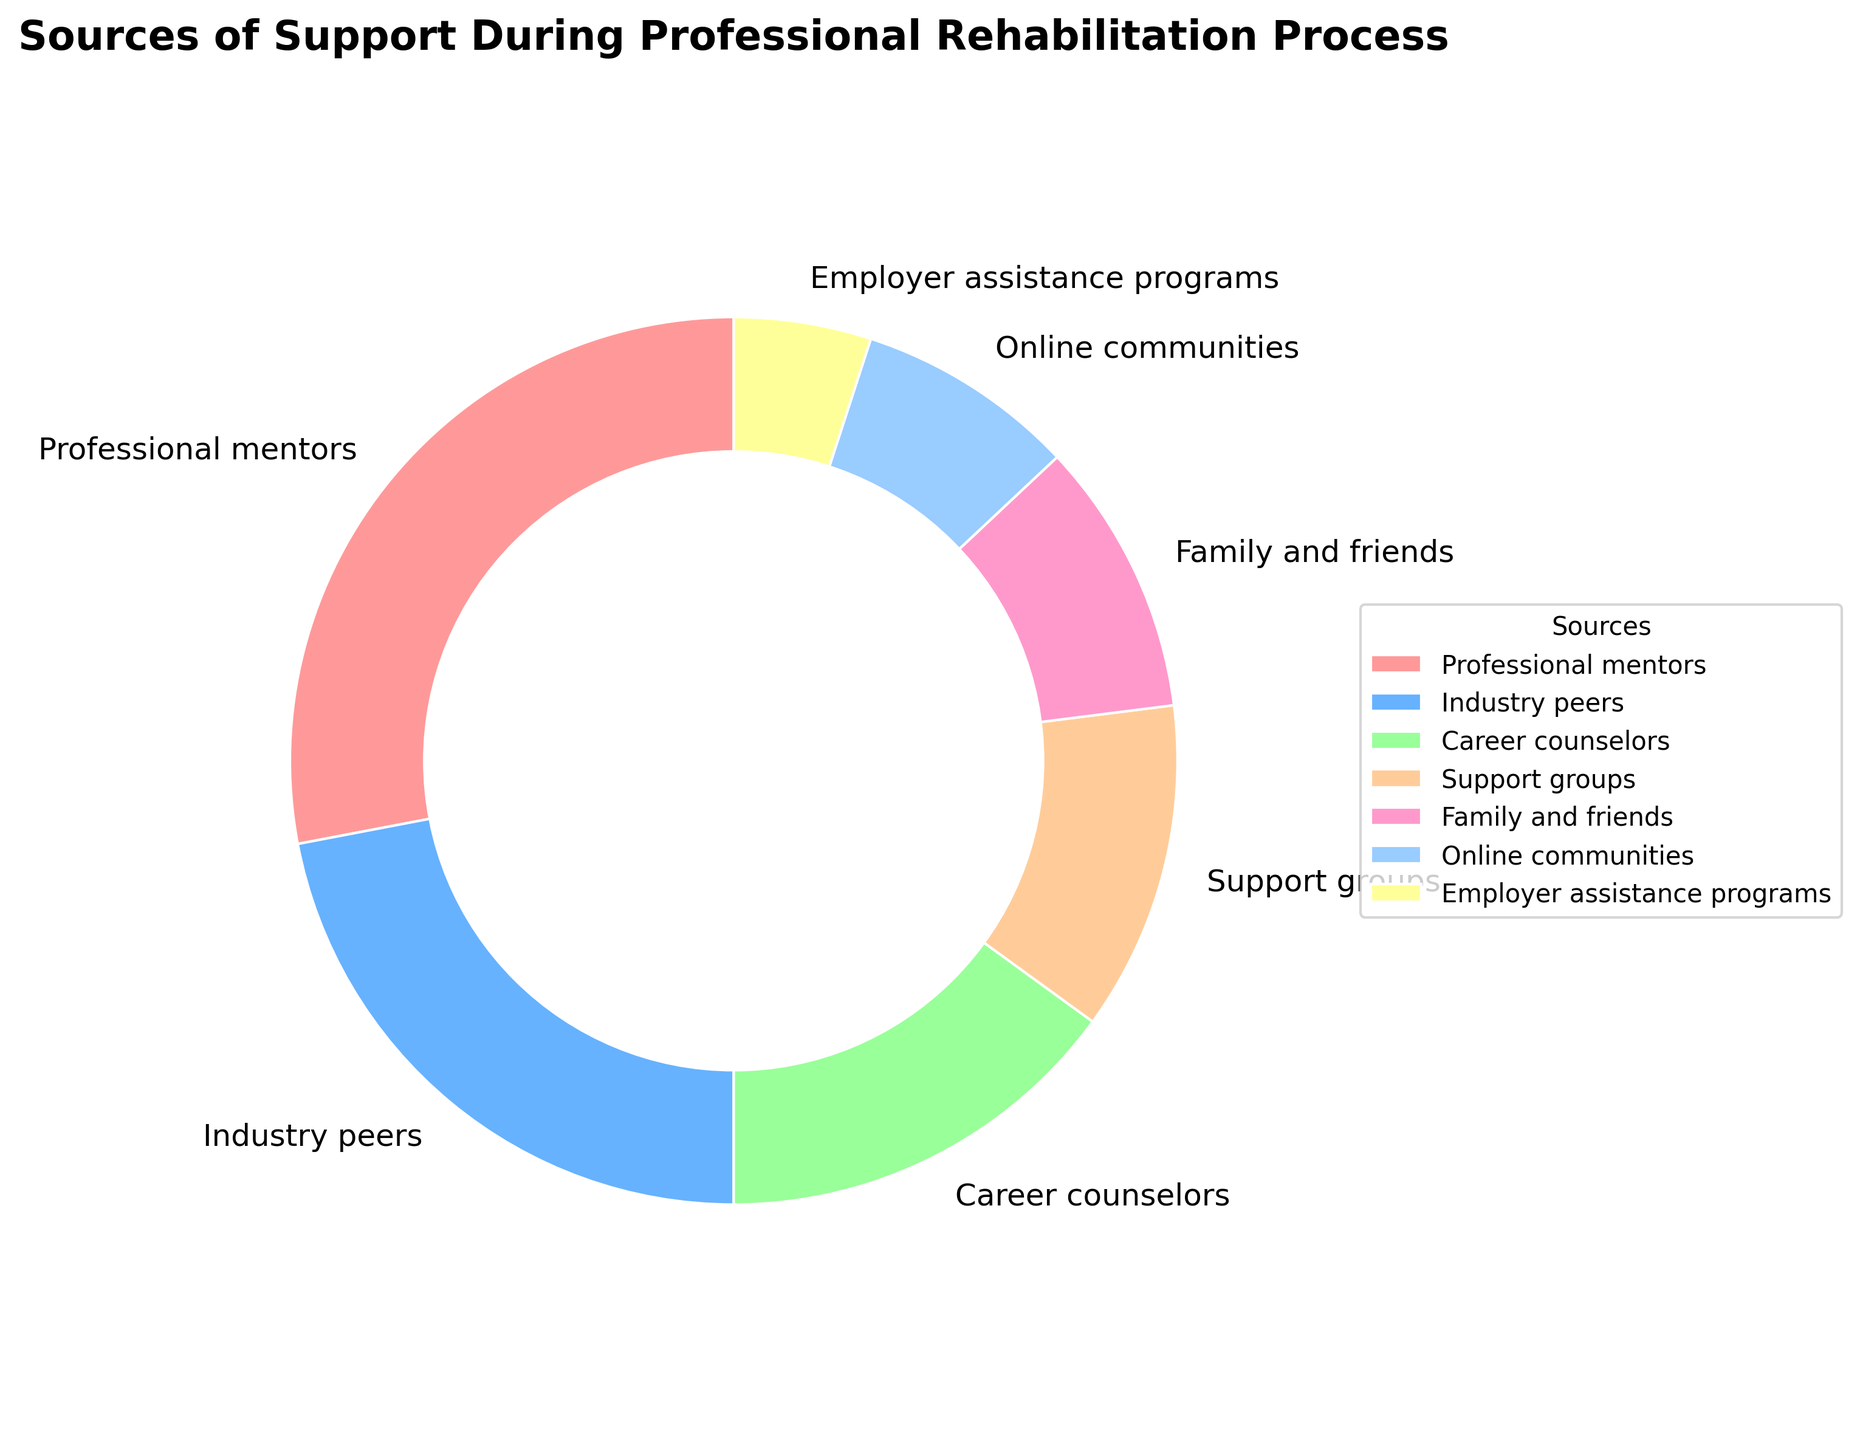Which source provides the highest percentage of support during the professional rehabilitation process? Look at the pie chart and identify the source with the largest slice. The 'Professional mentors' slice appears to be the largest.
Answer: Professional mentors Which source has the smallest percentage of support? Look at the pie chart and find the source with the smallest slice. The 'Employer assistance programs' slice is the smallest.
Answer: Employer assistance programs How much more support do professional mentors provide compared to family and friends? Subtract the percentage of 'Family and friends' from 'Professional mentors' (28% - 10% = 18%).
Answer: 18% What is the combined percentage of support from career counselors and support groups? Add the percentages of 'Career counselors' and 'Support groups' (15% + 12% = 27%).
Answer: 27% Which two sources together provide a third of the total support? Find two sources whose combined percentages equal approximately 33%. 'Career counselors' and 'Support groups' combined provide 27%, and 'Industry peers' and 'Online communities' combined provide 30%. The combination closest to 33% is 'Career counselors' and 'Support groups'.
Answer: Career counselors and Support groups Is the percentage of support provided by online communities greater or less than the percentage provided by family and friends? Compare the slices representing 'Online communities' and 'Family and friends'. The slice for 'Family and friends' is larger.
Answer: Less What is the difference in the percentage of support between industry peers and employer assistance programs? Subtract the percentage of 'Employer assistance programs' from 'Industry peers' (22% - 5% = 17%).
Answer: 17% Which source has a visually distinct color compared to the others? Look at the pie chart and identify any source with a very different color. 'Professional mentors' has a distinct red color compared to the others.
Answer: Professional mentors What is the average percentage of support provided by industry peers, family and friends, and online communities? Add the percentages of 'Industry peers', 'Family and friends', and 'Online communities', then divide by 3 ((22% + 10% + 8%) / 3 = 13.33%).
Answer: 13.33% 